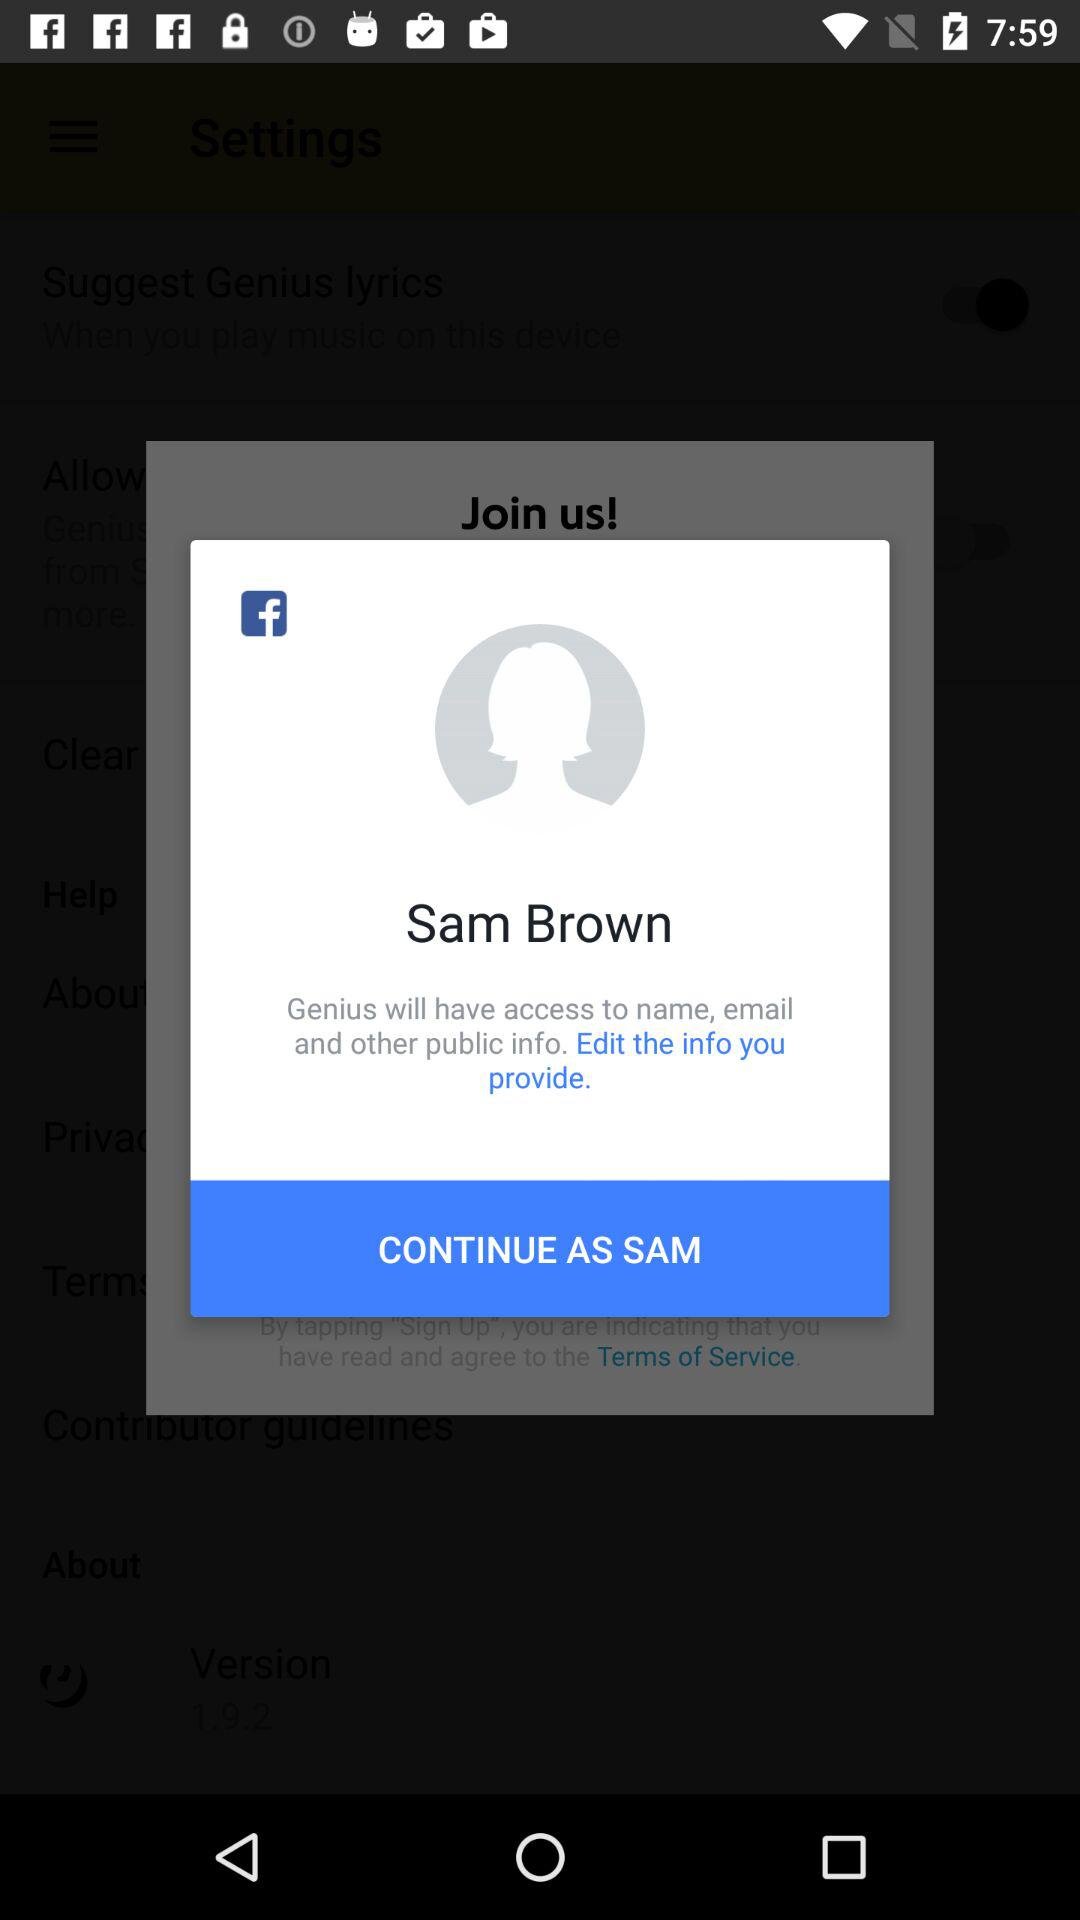Who has access to your name, email, and other publicly available information? The name, email, and other publicly available information accessed by "Genius". 